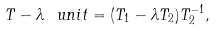<formula> <loc_0><loc_0><loc_500><loc_500>T - \lambda \ u n i t = ( T _ { 1 } - \lambda T _ { 2 } ) T _ { 2 } ^ { - 1 } ,</formula> 